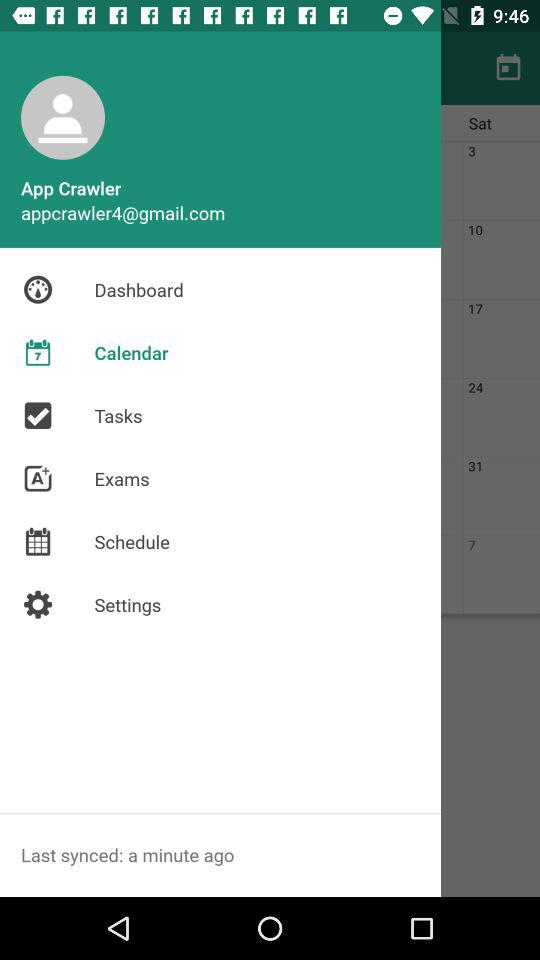What is the email address of the user? The email address of the user is appcrawler4@gmail.com. 